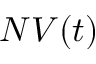<formula> <loc_0><loc_0><loc_500><loc_500>N V ( t )</formula> 